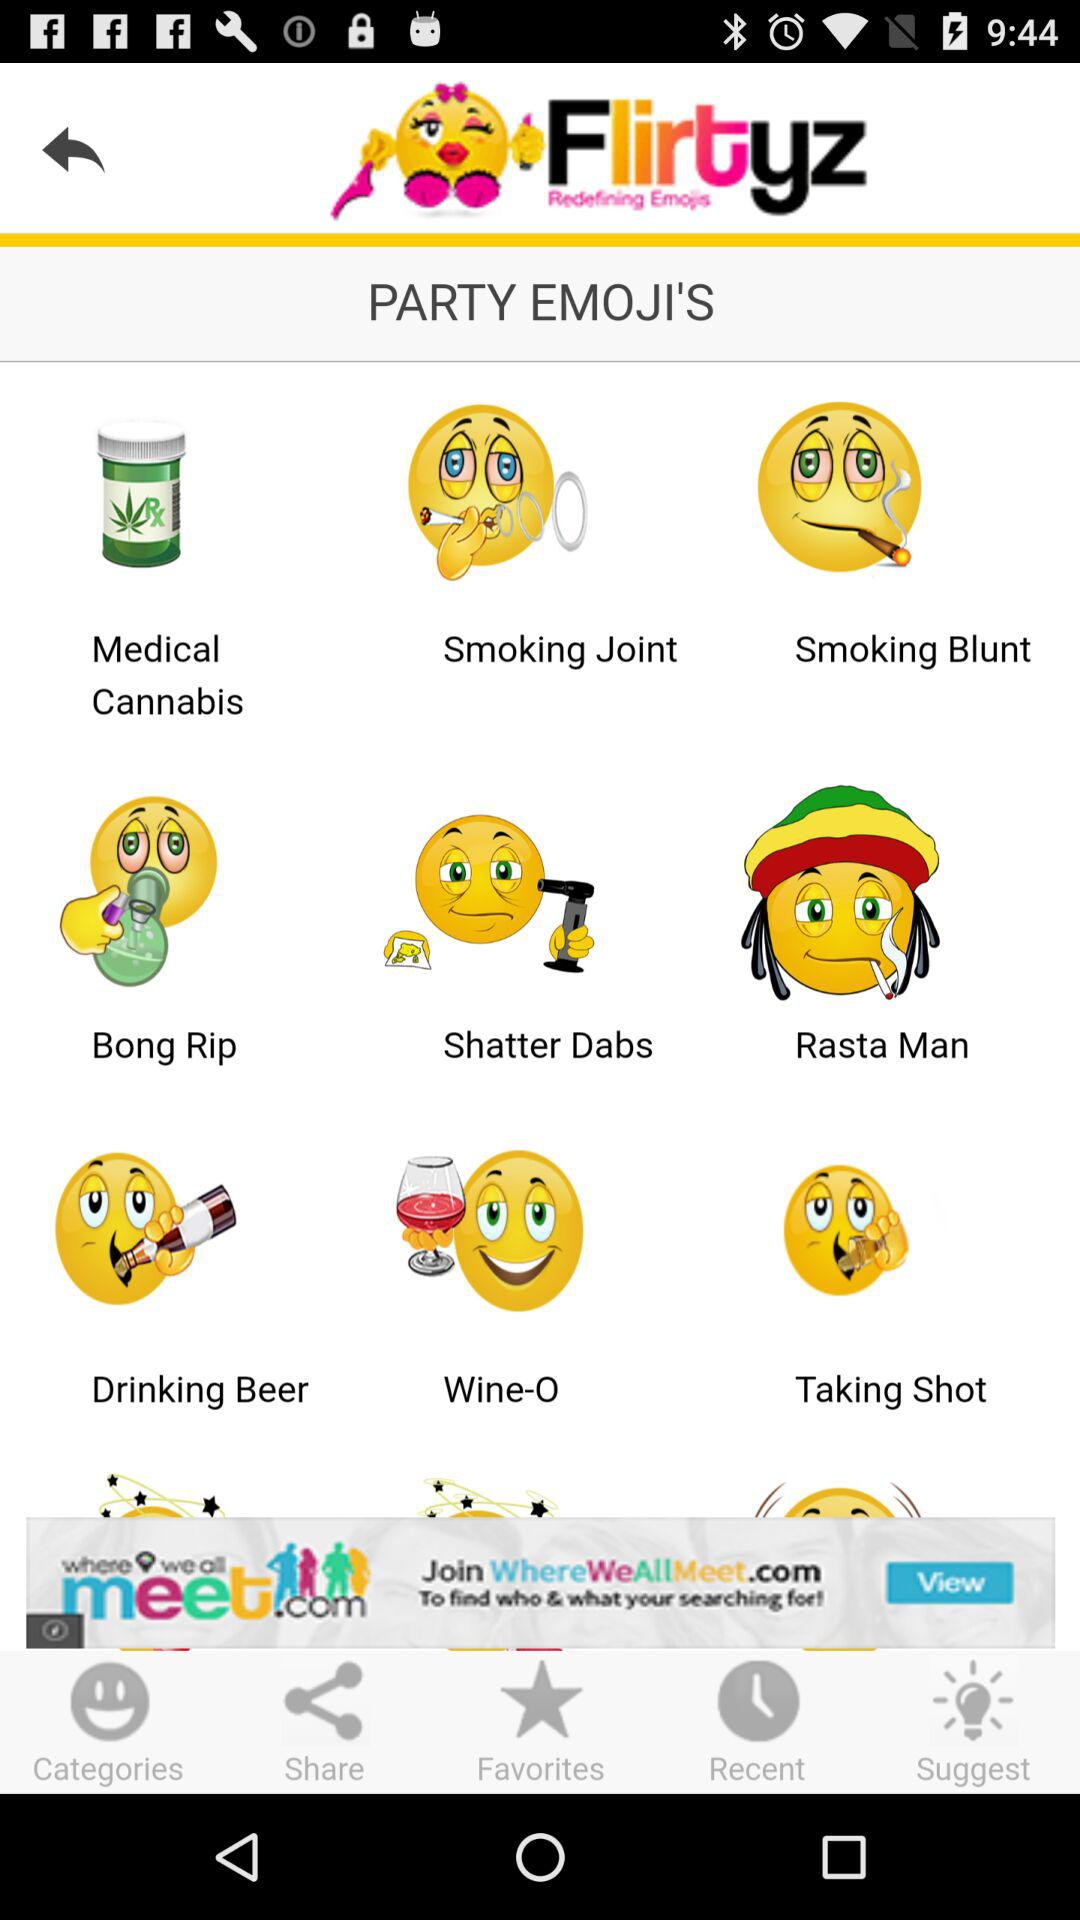What is the name of the application? The name of the application is "Flirtyz". 